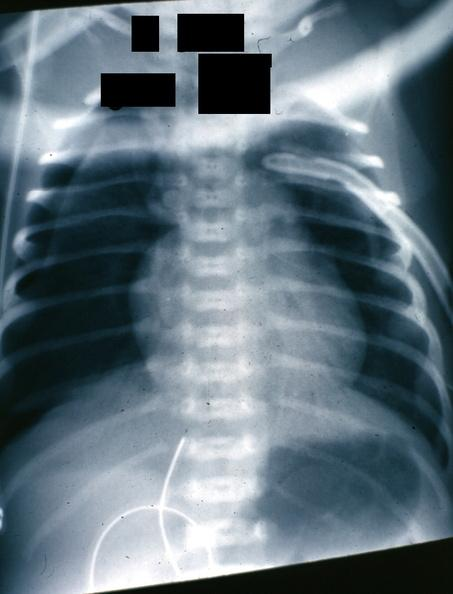s lung present?
Answer the question using a single word or phrase. Yes 